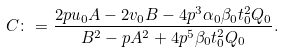Convert formula to latex. <formula><loc_0><loc_0><loc_500><loc_500>C \colon = \frac { 2 p u _ { 0 } A - 2 v _ { 0 } B - 4 p ^ { 3 } \alpha _ { 0 } \beta _ { 0 } t _ { 0 } ^ { 2 } Q _ { 0 } } { B ^ { 2 } - p A ^ { 2 } + 4 p ^ { 5 } \beta _ { 0 } t _ { 0 } ^ { 2 } Q _ { 0 } } .</formula> 